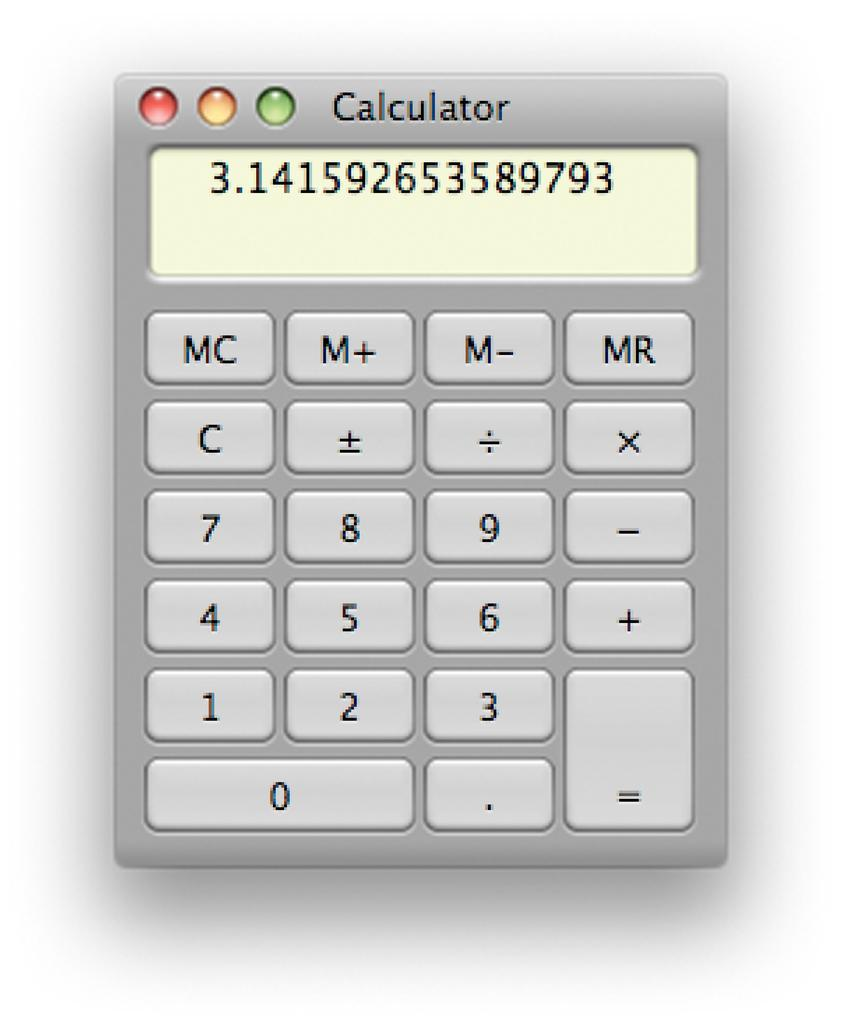Provide a one-sentence caption for the provided image. A calculator with the number 3.141592653589793 on the screen. 